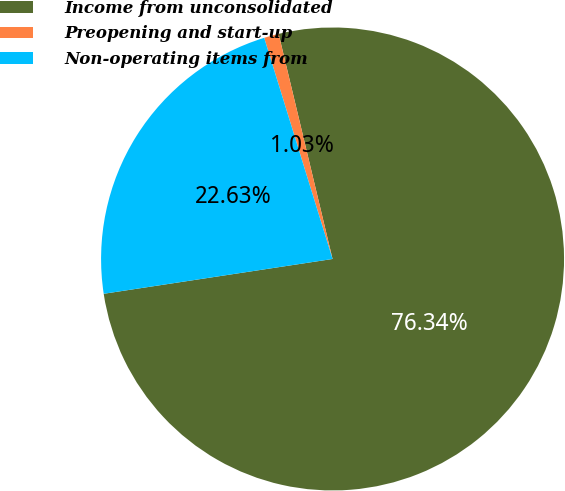<chart> <loc_0><loc_0><loc_500><loc_500><pie_chart><fcel>Income from unconsolidated<fcel>Preopening and start-up<fcel>Non-operating items from<nl><fcel>76.34%<fcel>1.03%<fcel>22.63%<nl></chart> 